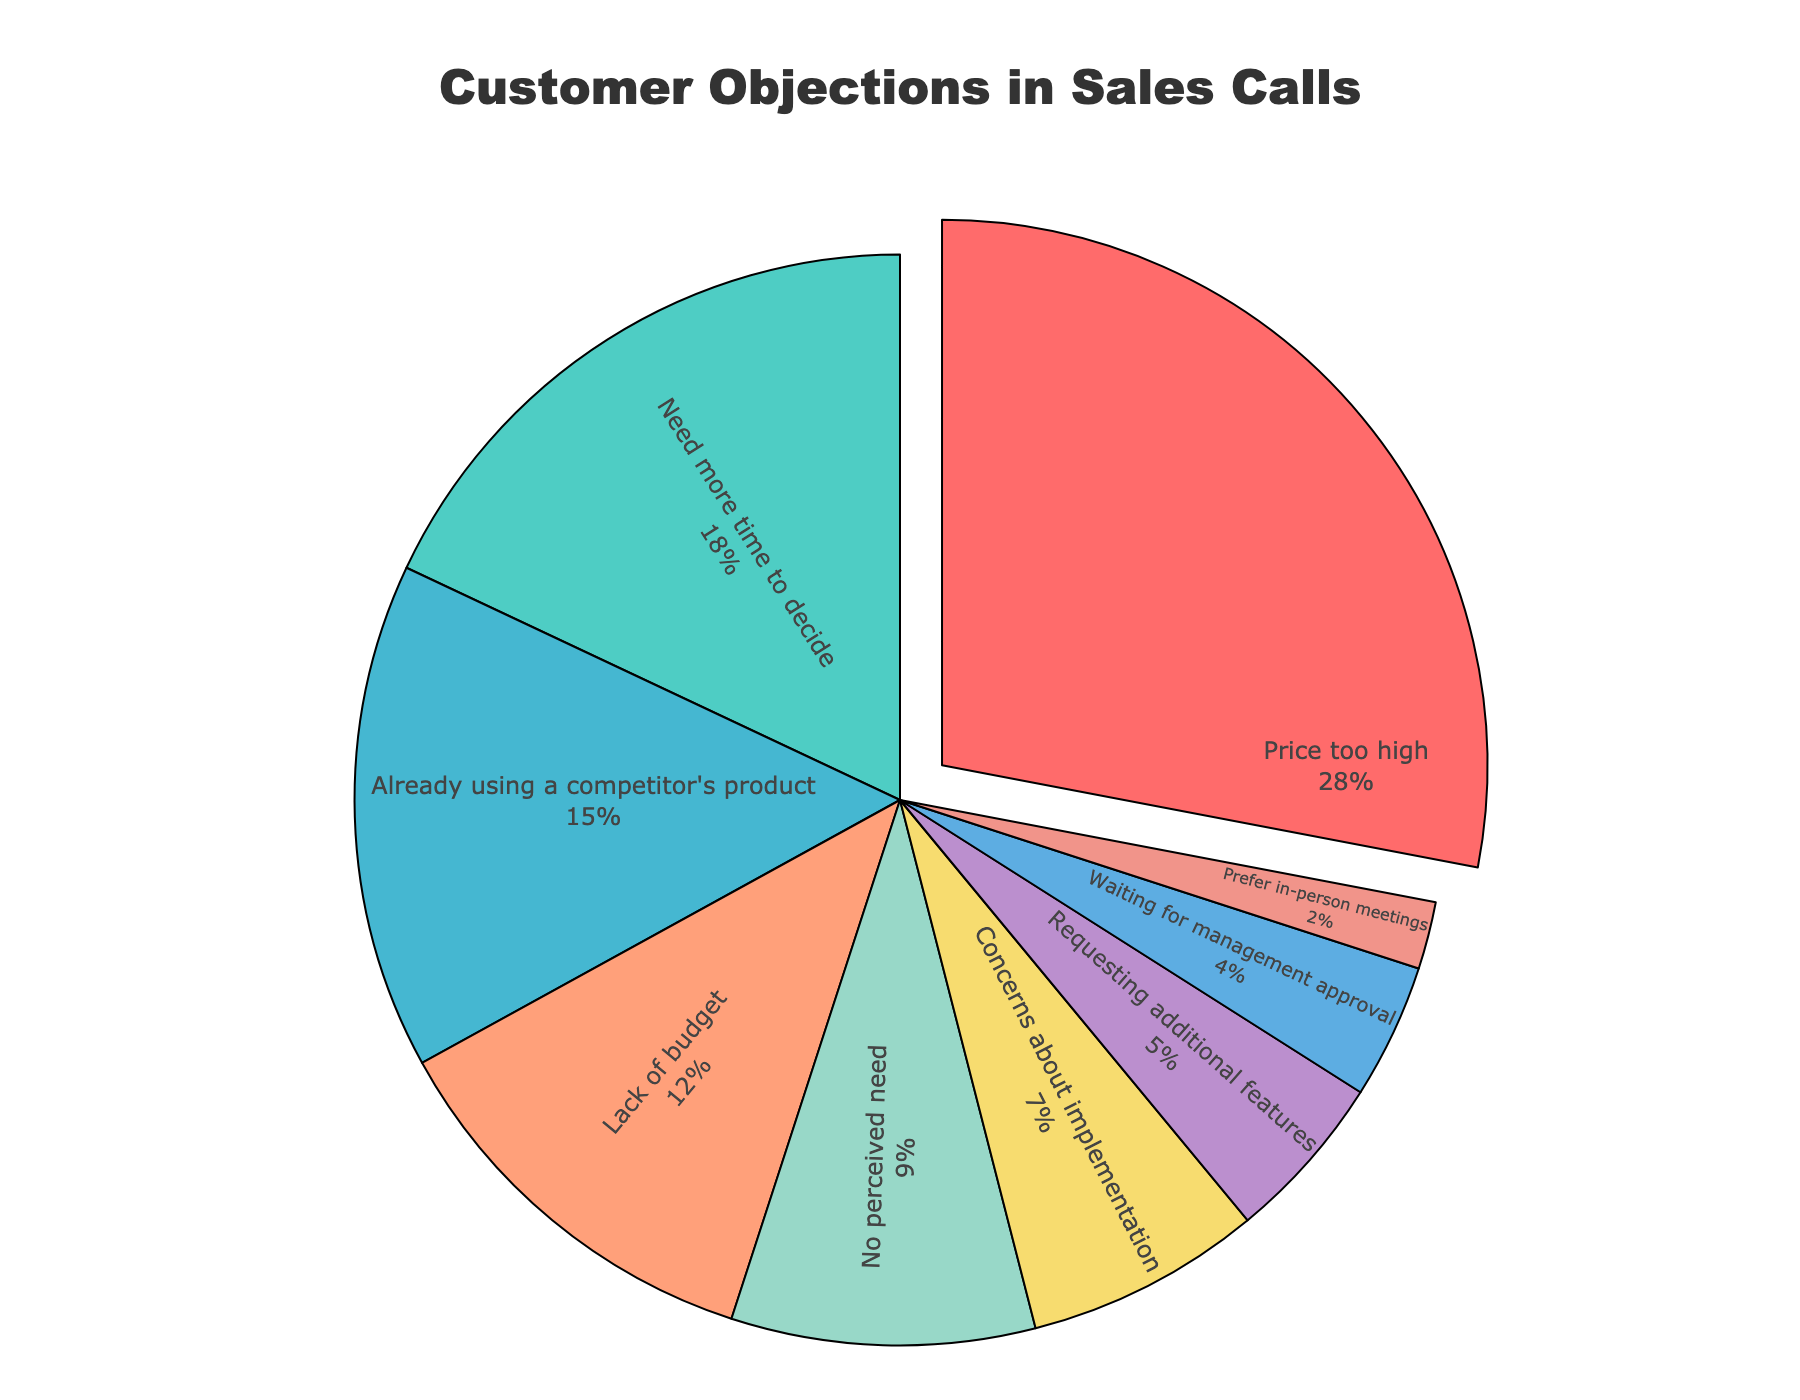What is the most common objection type? The chart shows the percentage distribution of various objection types. The segment with the highest percentage represents the most common objection type, which is "Price too high" at 28%.
Answer: Price too high Which two objection types together account for the highest combined percentage? To find the two objection types with the highest combined percentage, look for the two largest segments in the chart. "Price too high" is the largest at 28%, and "Need more time to decide" is next at 18%. Their combined percentage is 28% + 18% = 46%.
Answer: Price too high and Need more time to decide Which objection type has the smallest percentage? Identify the smallest segment in the pie chart. The segment representing "Prefer in-person meetings" is the smallest, contributing to only 2% of the objections.
Answer: Prefer in-person meetings What is the combined percentage of objections related to financial constraints (Price too high, Lack of budget)? Add the percentages of "Price too high" and "Lack of budget". These are 28% and 12%, respectively. The combined percentage is 28% + 12% = 40%.
Answer: 40% By how much does the "Price too high" objection exceed the "Lack of budget" objection? Subtract the percentage of "Lack of budget" from "Price too high". These are 28% and 12%, respectively. So, 28% - 12% = 16%.
Answer: 16% How do the objections "Already using a competitor's product" and "Need more time to decide" compare in percentage? Compare the percentages of the two objection types. "Already using a competitor's product" is 15%, while "Need more time to decide" is 18%. 18% is greater than 15%, so "Need more time to decide" is higher.
Answer: Need more time to decide is higher What is the total percentage of the objections related to decision-making (Need more time to decide, Waiting for management approval)? Add the percentages of "Need more time to decide" and "Waiting for management approval". These are 18% and 4%, respectively. The total percentage is 18% + 4% = 22%.
Answer: 22% What is the difference in percentage points between "Concerns about implementation" and "Requesting additional features"? Subtract the percentage of "Requesting additional features" from "Concerns about implementation". These are 7% and 5%, respectively. So, 7% - 5% = 2%.
Answer: 2% Which objection type is represented by the green segment? The pie chart uses colors to differentiate objection types. The green segment corresponds to "Need more time to decide", which is 18%.
Answer: Need more time to decide 